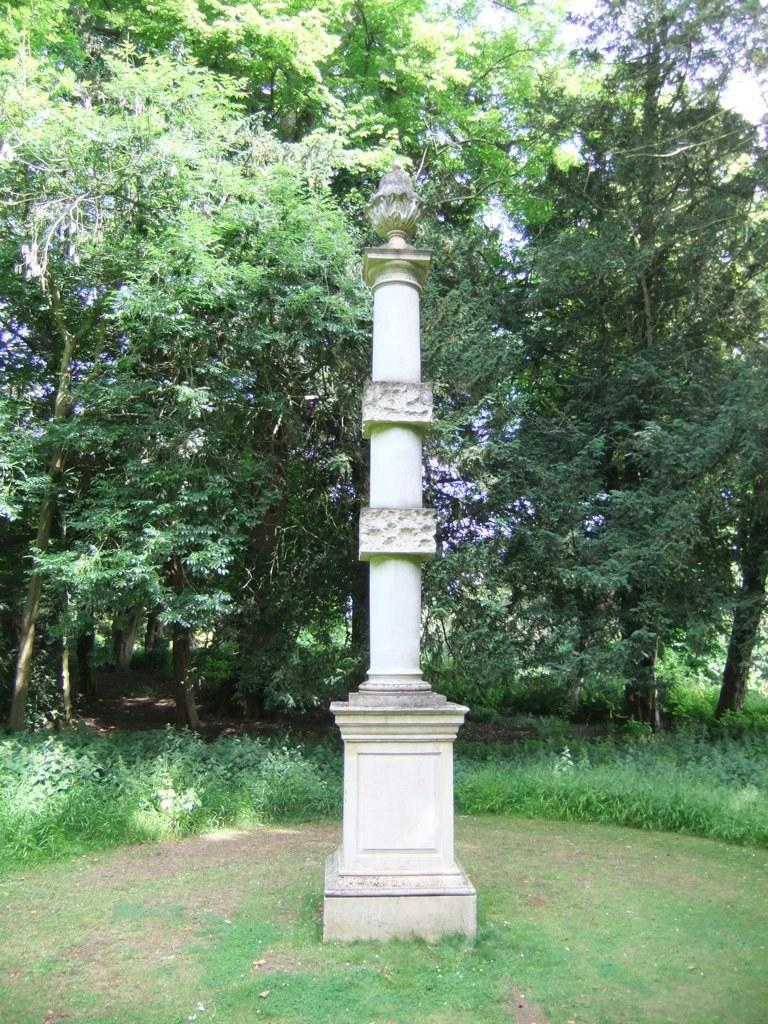What is the main feature in the center of the image? There is a pillar-like solid structure in the center of the image. What can be seen in the background of the image? There are trees and grass in the background of the image. What color is the crayon used to draw the attention of the viewer in the image? There is no crayon or drawing present in the image, so it is not possible to determine the color or any attention-grabbing elements. 